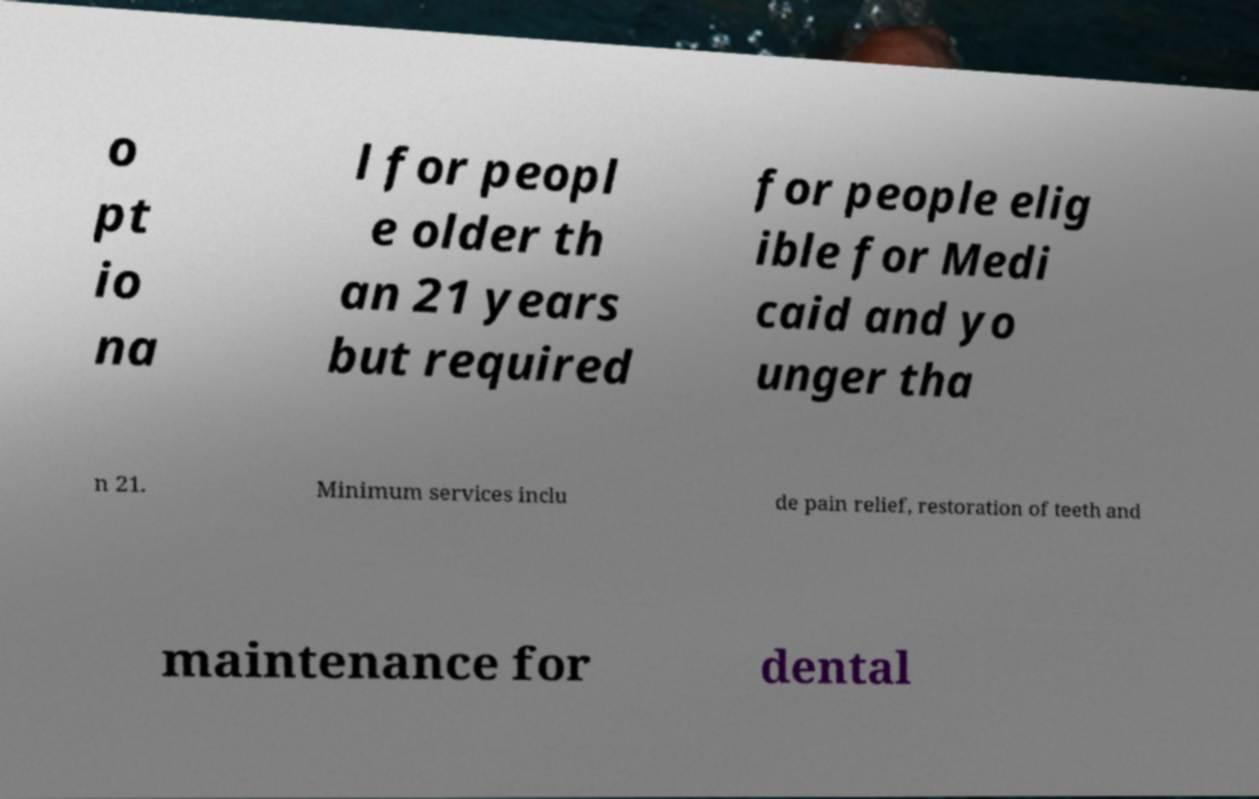There's text embedded in this image that I need extracted. Can you transcribe it verbatim? o pt io na l for peopl e older th an 21 years but required for people elig ible for Medi caid and yo unger tha n 21. Minimum services inclu de pain relief, restoration of teeth and maintenance for dental 